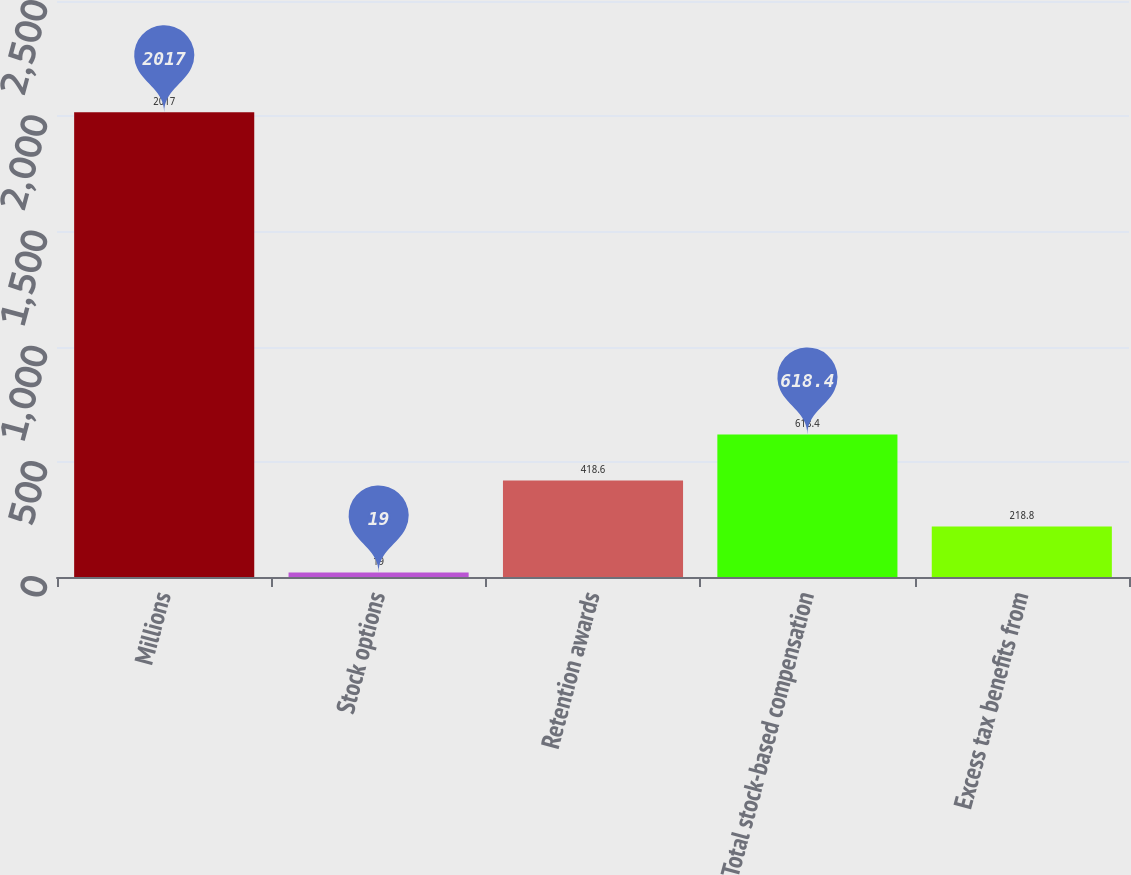Convert chart. <chart><loc_0><loc_0><loc_500><loc_500><bar_chart><fcel>Millions<fcel>Stock options<fcel>Retention awards<fcel>Total stock-based compensation<fcel>Excess tax benefits from<nl><fcel>2017<fcel>19<fcel>418.6<fcel>618.4<fcel>218.8<nl></chart> 